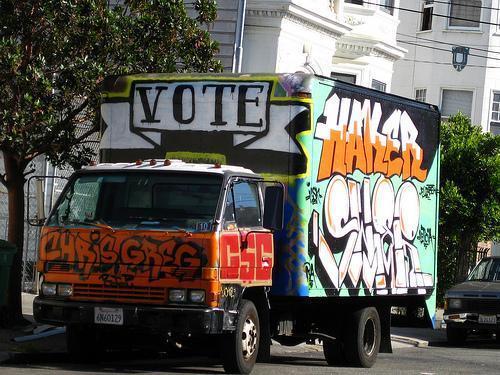How many colors are on the side of the truck?
Give a very brief answer. 4. 